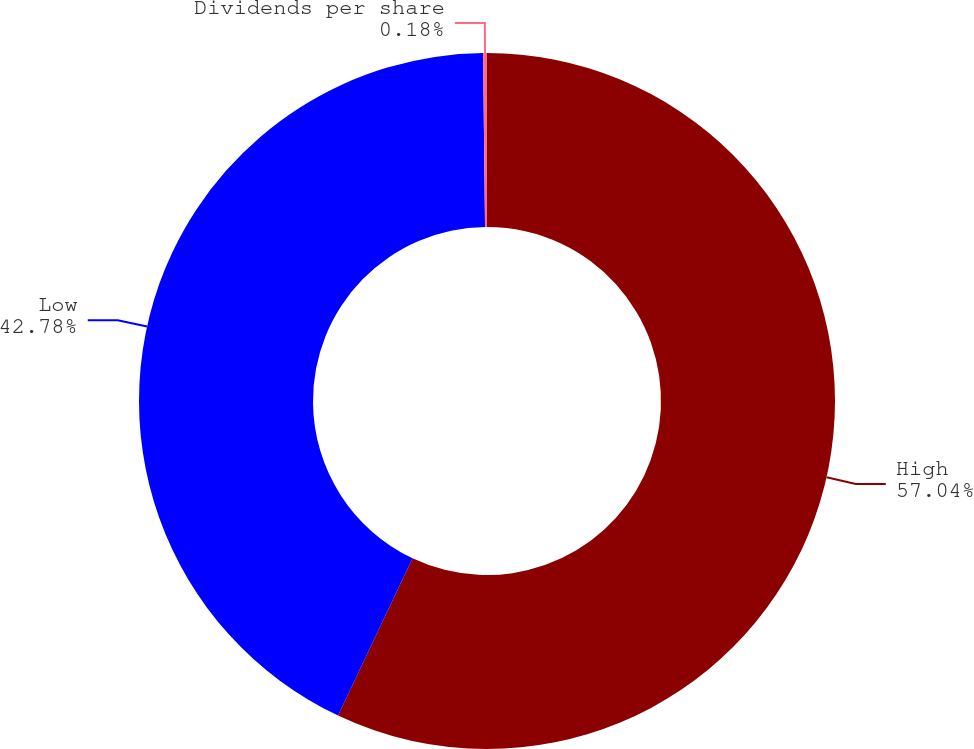Convert chart to OTSL. <chart><loc_0><loc_0><loc_500><loc_500><pie_chart><fcel>High<fcel>Low<fcel>Dividends per share<nl><fcel>57.04%<fcel>42.78%<fcel>0.18%<nl></chart> 